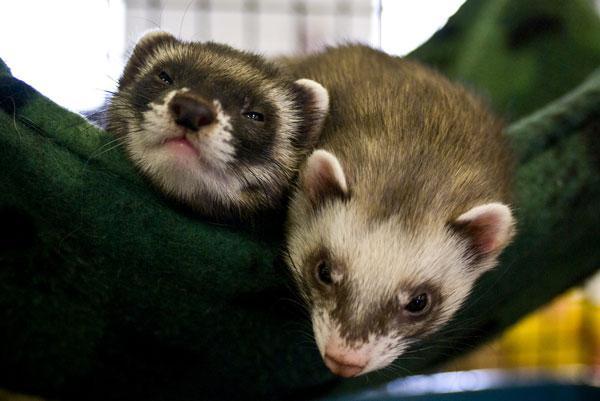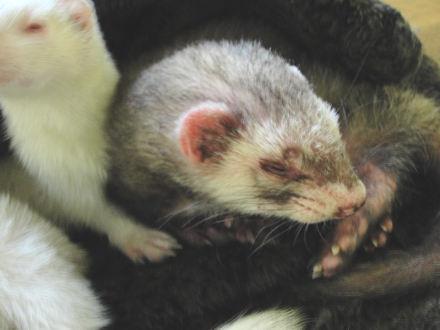The first image is the image on the left, the second image is the image on the right. Considering the images on both sides, is "At least one image contains multiple ferrets, and at least one image includes a ferret in a resting pose." valid? Answer yes or no. Yes. The first image is the image on the left, the second image is the image on the right. Examine the images to the left and right. Is the description "At least one of the images has exactly one ferret." accurate? Answer yes or no. No. 